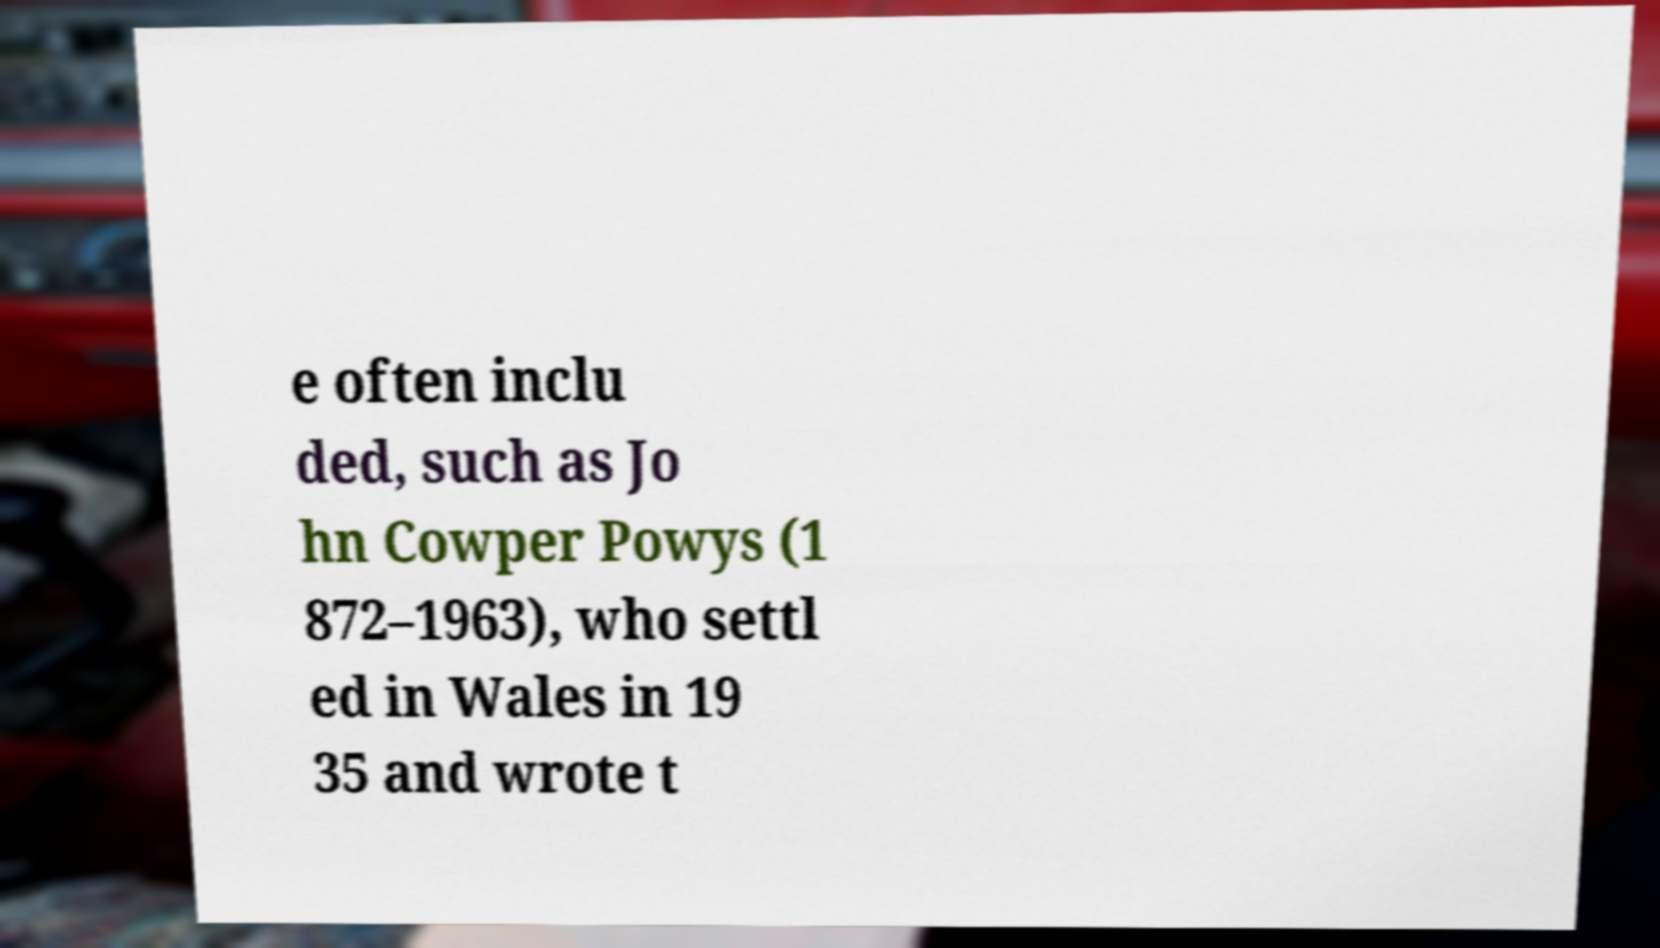Please identify and transcribe the text found in this image. e often inclu ded, such as Jo hn Cowper Powys (1 872–1963), who settl ed in Wales in 19 35 and wrote t 